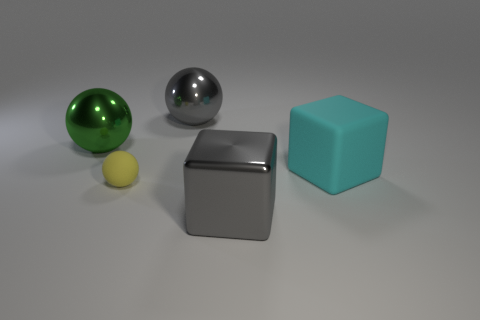Subtract all big gray metallic balls. How many balls are left? 2 Subtract 1 green spheres. How many objects are left? 4 Subtract all spheres. How many objects are left? 2 Subtract 1 spheres. How many spheres are left? 2 Subtract all yellow spheres. Subtract all gray cylinders. How many spheres are left? 2 Subtract all green cylinders. How many cyan blocks are left? 1 Subtract all tiny brown metal objects. Subtract all shiny balls. How many objects are left? 3 Add 4 big shiny spheres. How many big shiny spheres are left? 6 Add 3 big gray objects. How many big gray objects exist? 5 Add 5 cyan matte cubes. How many objects exist? 10 